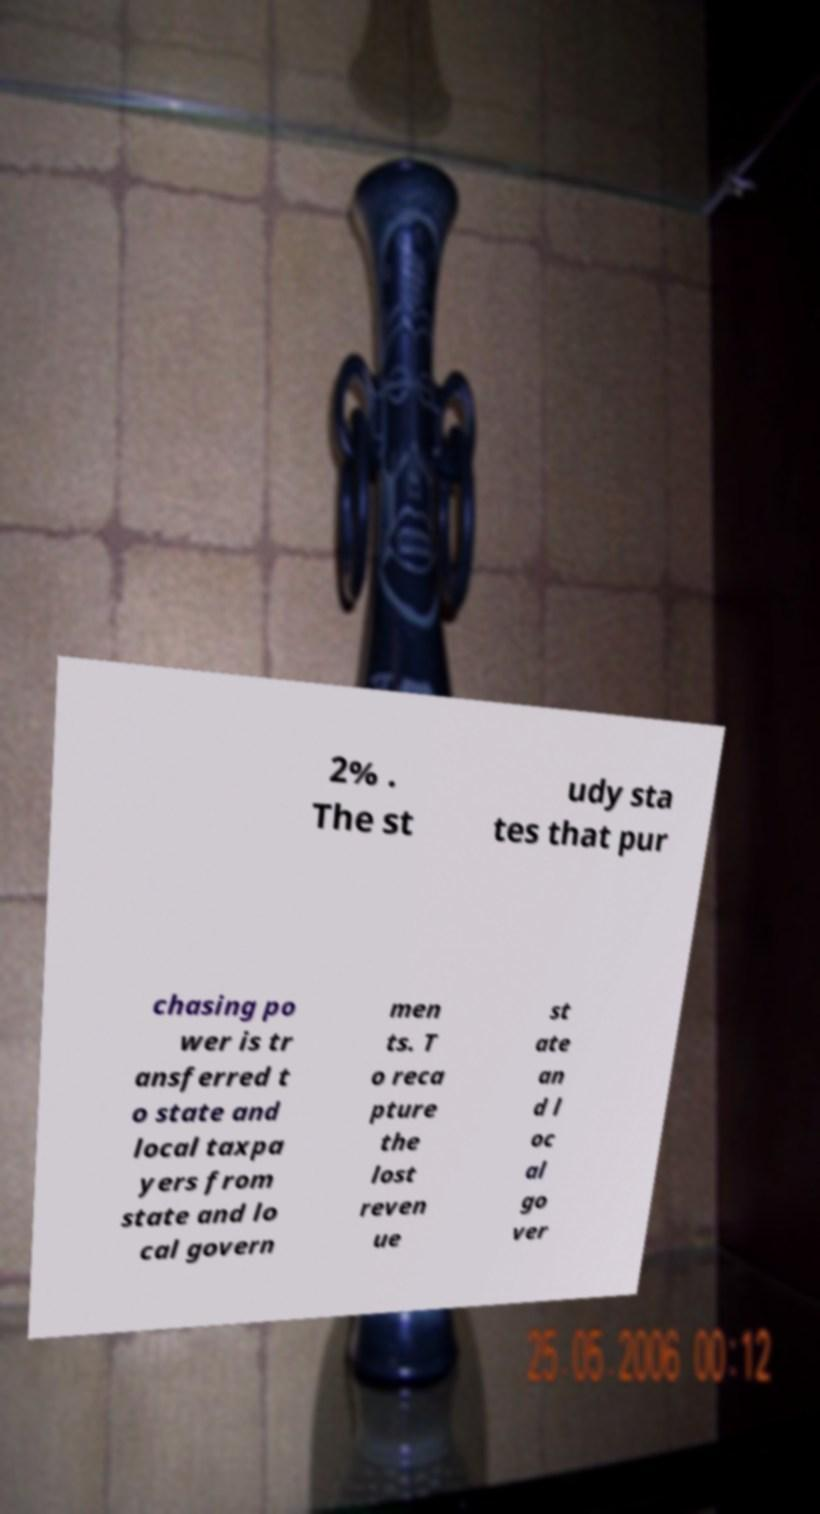What messages or text are displayed in this image? I need them in a readable, typed format. 2% . The st udy sta tes that pur chasing po wer is tr ansferred t o state and local taxpa yers from state and lo cal govern men ts. T o reca pture the lost reven ue st ate an d l oc al go ver 